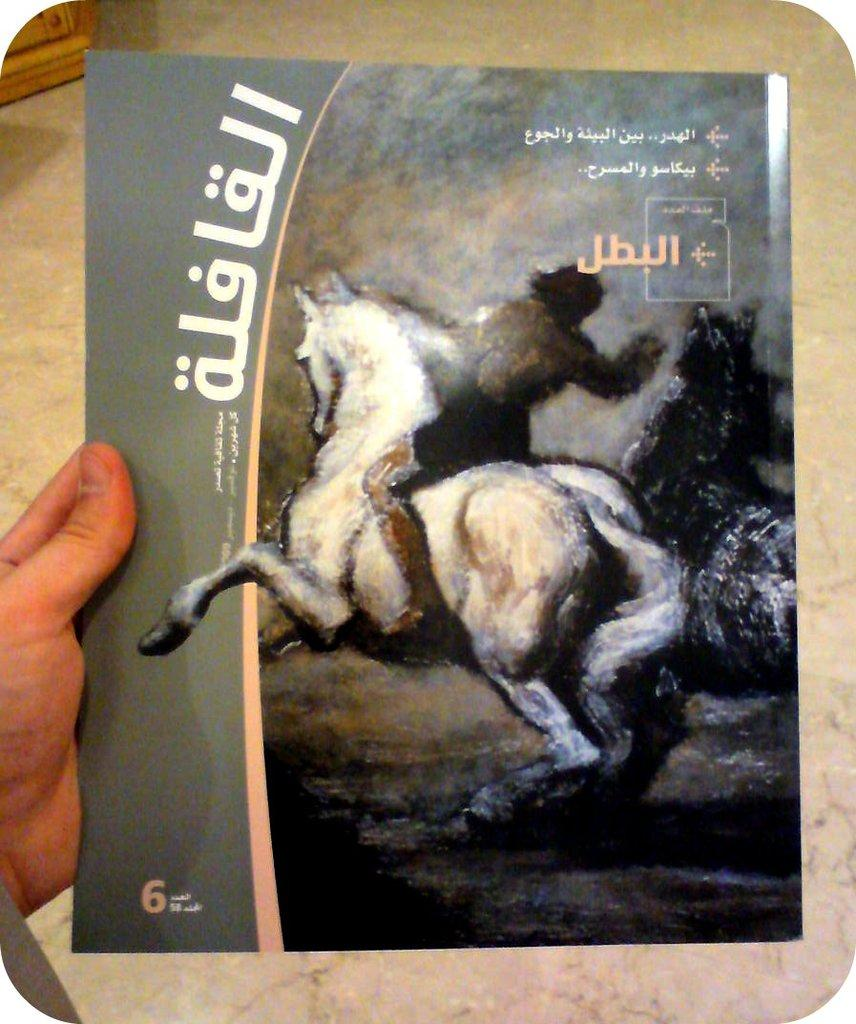<image>
Relay a brief, clear account of the picture shown. A hand holding an image with the number six in the corner 